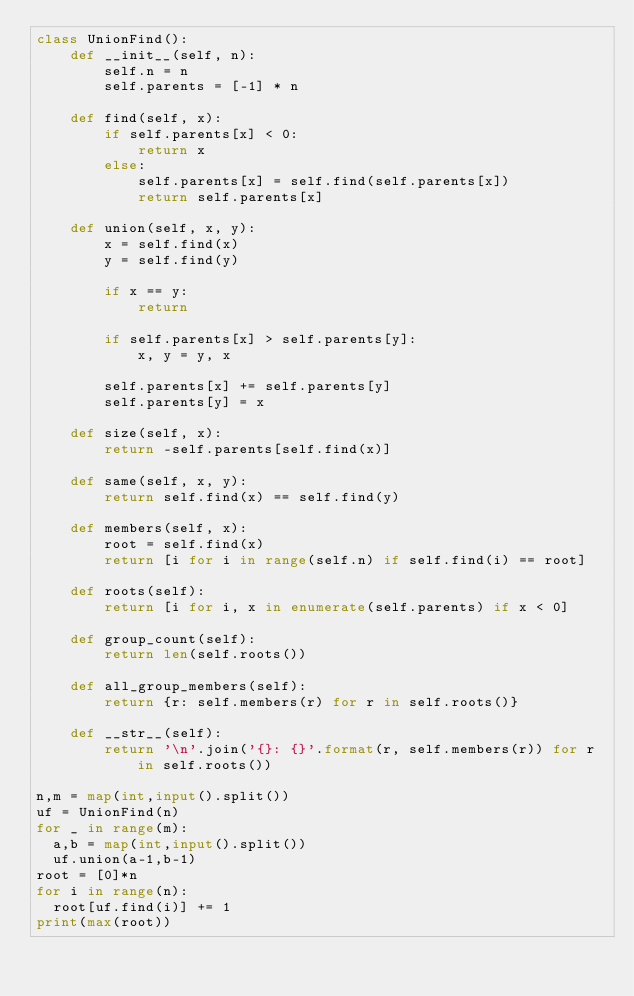Convert code to text. <code><loc_0><loc_0><loc_500><loc_500><_Python_>class UnionFind():
    def __init__(self, n):
        self.n = n
        self.parents = [-1] * n

    def find(self, x):
        if self.parents[x] < 0:
            return x
        else:
            self.parents[x] = self.find(self.parents[x])
            return self.parents[x]

    def union(self, x, y):
        x = self.find(x)
        y = self.find(y)

        if x == y:
            return

        if self.parents[x] > self.parents[y]:
            x, y = y, x

        self.parents[x] += self.parents[y]
        self.parents[y] = x

    def size(self, x):
        return -self.parents[self.find(x)]

    def same(self, x, y):
        return self.find(x) == self.find(y)

    def members(self, x):
        root = self.find(x)
        return [i for i in range(self.n) if self.find(i) == root]

    def roots(self):
        return [i for i, x in enumerate(self.parents) if x < 0]

    def group_count(self):
        return len(self.roots())

    def all_group_members(self):
        return {r: self.members(r) for r in self.roots()}

    def __str__(self):
        return '\n'.join('{}: {}'.format(r, self.members(r)) for r in self.roots())

n,m = map(int,input().split())
uf = UnionFind(n)
for _ in range(m):
  a,b = map(int,input().split())
  uf.union(a-1,b-1)
root = [0]*n
for i in range(n):
  root[uf.find(i)] += 1
print(max(root))</code> 